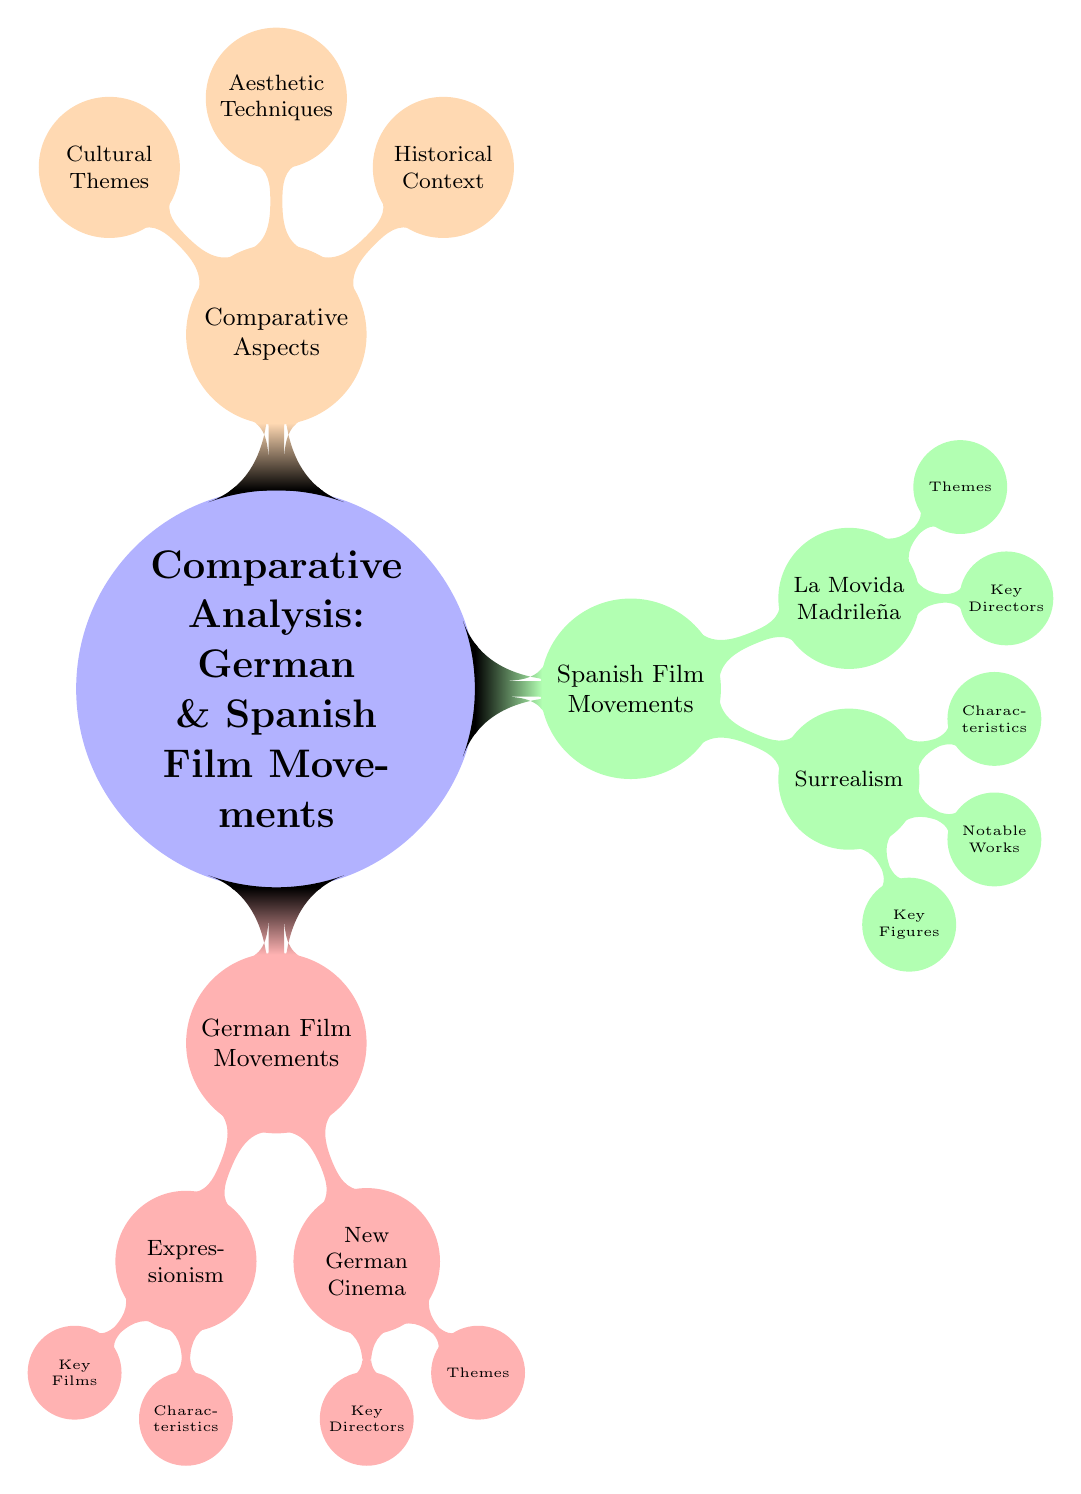What are the two major German film movements depicted? The diagram highlights two major German film movements: Expressionism and New German Cinema. Both are primary nodes branching directly from the German Film Movements node.
Answer: Expressionism and New German Cinema Who are the key figures associated with Spanish Surrealism? The diagram specifies that the key figures associated with Spanish Surrealism are Luis Buñuel and Salvador Dalí. This information is found in the node directly connected to Surrealism.
Answer: Luis Buñuel and Salvador Dalí What thematic focus is shared by both German and Spanish film movements? Analyzing the Cultural Themes node, the shared focus among German and Spanish movements is the exploration of political and social liberation themes, such as War Aftermath and Political Repression.
Answer: War Aftermath and Political Repression How many characteristics does German Expressionism have listed in the diagram? The German Expressionism node lists three characteristics: Distorted Sets, High Contrast Lighting, and Abstract Use of Shadows. Thus, the count of characteristics is three.
Answer: Three Which Spanish film movement is characterized by Post-Franco freedom? The diagram shows that La Movida Madrileña is the Spanish film movement characterized specifically by Post-Franco freedom, as indicated in the Themes node under that movement.
Answer: La Movida Madrileña What aesthetic techniques are associated with German Expressionism and Spanish Surrealism? The diagram presents aesthetic techniques under the Comparative Aspects node, linking German Expressionism to High Contrast Lighting and Distorted Sets, while Spanish Surrealism has Dream-like Quality and Irrational Juxtapositions. Both sets of techniques can be identified within their respective nodes.
Answer: High Contrast Lighting and Dream-like Quality Which director is NOT associated with New German Cinema? The diagram specifies three directors connected to New German Cinema: Rainer Werner Fassbinder, Werner Herzog, and Wim Wenders. Any mention of a director outside this list indicates they are not associated, for example, Pedro Almodóvar is associated with La Movida Madrileña.
Answer: Pedro Almodóvar What was the historical context surrounding Spanish film movements? Looking at the Historical Context node for Spanish film movements, they occurred during the Post-Spanish Civil War and Post-Franco Era, revealing the influence of these historical events on films from that period.
Answer: Post-Spanish Civil War and Post-Franco Era 